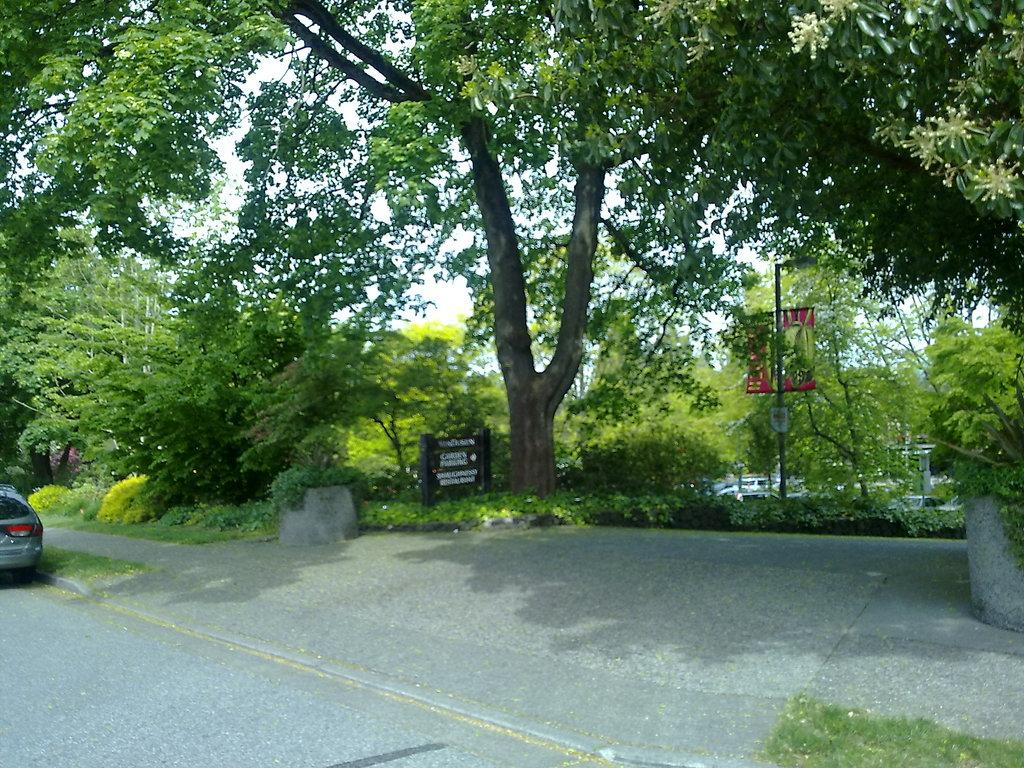What type of vegetation can be seen in the image? There is a group of trees, plants, and grass in the image. What man-made objects are present in the image? There is a street sign, a banner on a pole, and vehicles on the ground in the image. What part of the natural environment is visible in the image? The sky is visible in the image. What type of gun can be seen in the hands of the person in the image? There is no person or gun present in the image. How many eggs are visible on the ground in the image? There are no eggs visible in the image. 